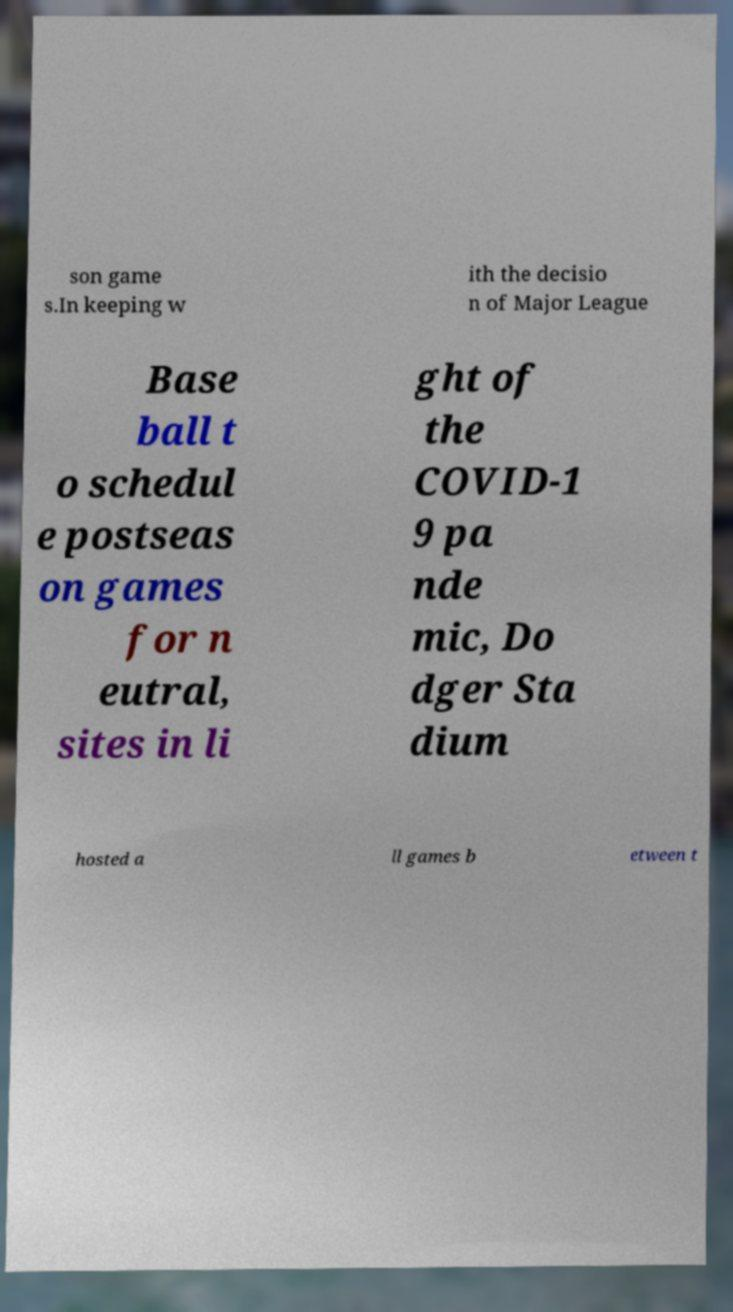Could you extract and type out the text from this image? son game s.In keeping w ith the decisio n of Major League Base ball t o schedul e postseas on games for n eutral, sites in li ght of the COVID-1 9 pa nde mic, Do dger Sta dium hosted a ll games b etween t 